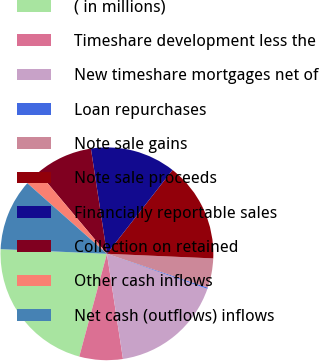<chart> <loc_0><loc_0><loc_500><loc_500><pie_chart><fcel>( in millions)<fcel>Timeshare development less the<fcel>New timeshare mortgages net of<fcel>Loan repurchases<fcel>Note sale gains<fcel>Note sale proceeds<fcel>Financially reportable sales<fcel>Collection on retained<fcel>Other cash inflows<fcel>Net cash (outflows) inflows<nl><fcel>21.51%<fcel>6.59%<fcel>17.25%<fcel>0.19%<fcel>4.46%<fcel>15.12%<fcel>12.98%<fcel>8.72%<fcel>2.33%<fcel>10.85%<nl></chart> 